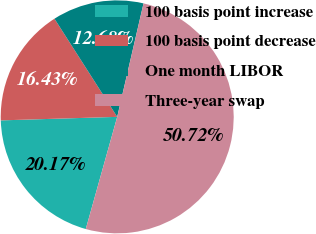Convert chart to OTSL. <chart><loc_0><loc_0><loc_500><loc_500><pie_chart><fcel>100 basis point increase<fcel>100 basis point decrease<fcel>One month LIBOR<fcel>Three-year swap<nl><fcel>20.17%<fcel>16.43%<fcel>12.68%<fcel>50.72%<nl></chart> 